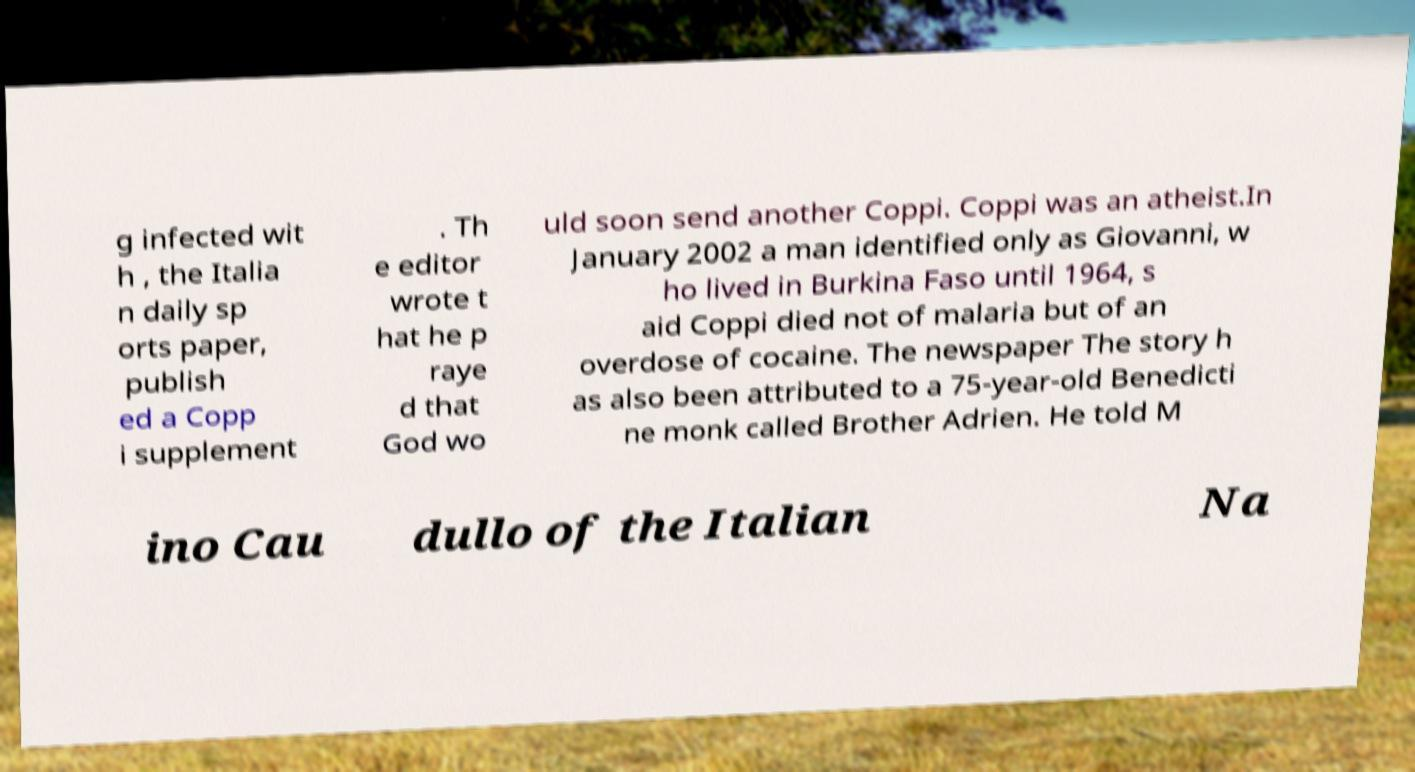What messages or text are displayed in this image? I need them in a readable, typed format. g infected wit h , the Italia n daily sp orts paper, publish ed a Copp i supplement . Th e editor wrote t hat he p raye d that God wo uld soon send another Coppi. Coppi was an atheist.In January 2002 a man identified only as Giovanni, w ho lived in Burkina Faso until 1964, s aid Coppi died not of malaria but of an overdose of cocaine. The newspaper The story h as also been attributed to a 75-year-old Benedicti ne monk called Brother Adrien. He told M ino Cau dullo of the Italian Na 